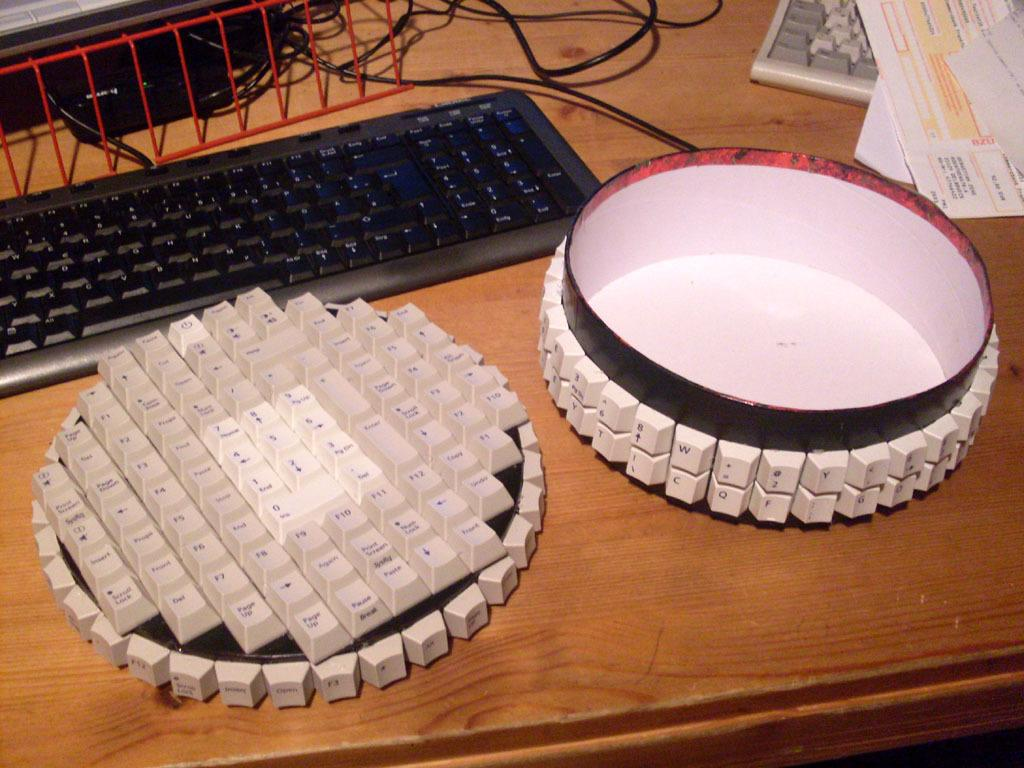What is located at the bottom of the image? There is a table at the bottom of the image. What is on the table? There is a keyboard on the table. How many different types of keyboards are on the table? There are different types of keyboards on the table. What else can be seen on the table besides the keyboards? There are papers and wires on the table. Can you see a tiger walking around the table in the image? No, there is no tiger present in the image. What type of bucket is used to hold the wires on the table? There is no bucket present in the image; the wires are simply lying on the table. 